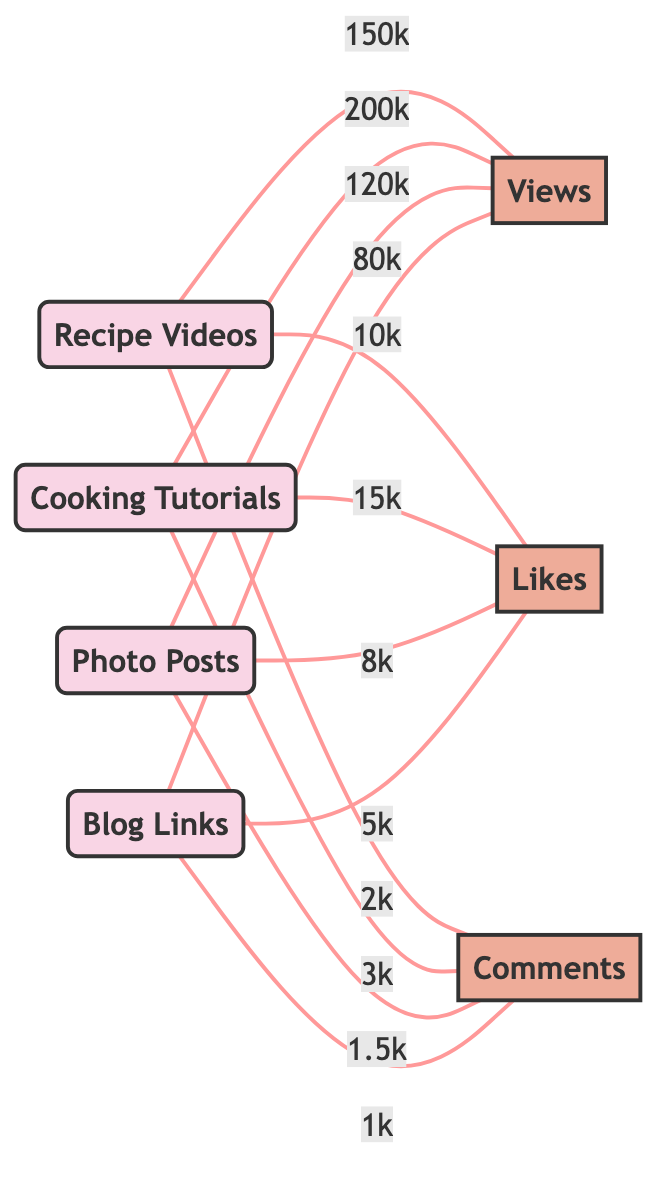What is the total number of content types displayed in the diagram? The diagram has 4 nodes representing content types: recipe videos, cooking tutorials, photo posts, and blog links. Therefore, the total number of content types is 4.
Answer: 4 Which content type has the highest number of likes? By examining the edges connected to likes, cooking tutorials has 15k likes, which is higher than the likes for the other content types (recipe videos: 10k, photo posts: 8k, blog links: 5k). Hence, cooking tutorials has the highest likes.
Answer: Cooking Tutorials What is the number of views for photo posts? The edge connecting photo posts to views indicates a value of 120k. Thus, the number of views for photo posts is 120k.
Answer: 120k Which content type has the lowest engagement in terms of comments? Looking at the edges connected to comments, blog links has the lowest value of 1k comments, compared to recipe videos (2k), cooking tutorials (3k), and photo posts (1.5k). Thus, blog links has the lowest comments.
Answer: Blog Links How many edges are connected to cooking tutorials? Cooking tutorials has three edges connected to it: one for views (200k), one for likes (15k), and one for comments (3k). Therefore, the total number of edges connected to cooking tutorials is 3.
Answer: 3 What is the difference in views between recipe videos and cooking tutorials? Recipe videos have 150k views, while cooking tutorials have 200k views. The difference in views is calculated as 200k (cooking tutorials) - 150k (recipe videos) = 50k.
Answer: 50k Which metric shows the highest value for recipe videos? Among the edges connected to recipe videos, views have the highest value of 150k, compared to likes (10k) and comments (2k). Thus, the highest metric for recipe videos is views.
Answer: Views What is the combined total of likes from all content types? The likes from all content types are: 10k (recipe videos) + 15k (cooking tutorials) + 8k (photo posts) + 5k (blog links) = 38k. Therefore, the combined total of likes is 38k.
Answer: 38k What is the average number of comments across all content types? The number of comments for each type are: recipe videos (2k), cooking tutorials (3k), photo posts (1.5k), and blog links (1k). The total comments = 2k + 3k + 1.5k + 1k = 7.5k, and dividing by the number of types (4) gives an average of 1.875k comments.
Answer: 1.875k 